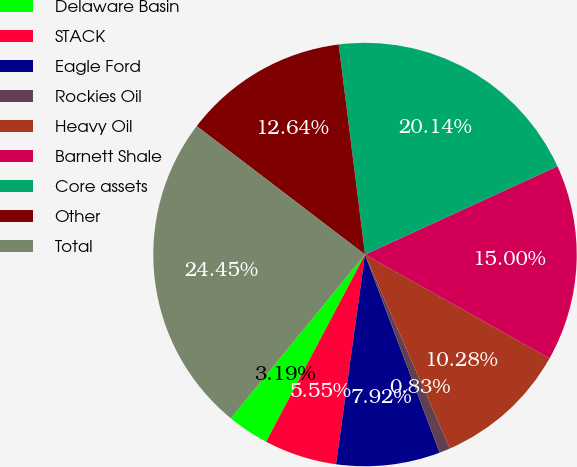Convert chart to OTSL. <chart><loc_0><loc_0><loc_500><loc_500><pie_chart><fcel>Delaware Basin<fcel>STACK<fcel>Eagle Ford<fcel>Rockies Oil<fcel>Heavy Oil<fcel>Barnett Shale<fcel>Core assets<fcel>Other<fcel>Total<nl><fcel>3.19%<fcel>5.55%<fcel>7.92%<fcel>0.83%<fcel>10.28%<fcel>15.0%<fcel>20.14%<fcel>12.64%<fcel>24.45%<nl></chart> 